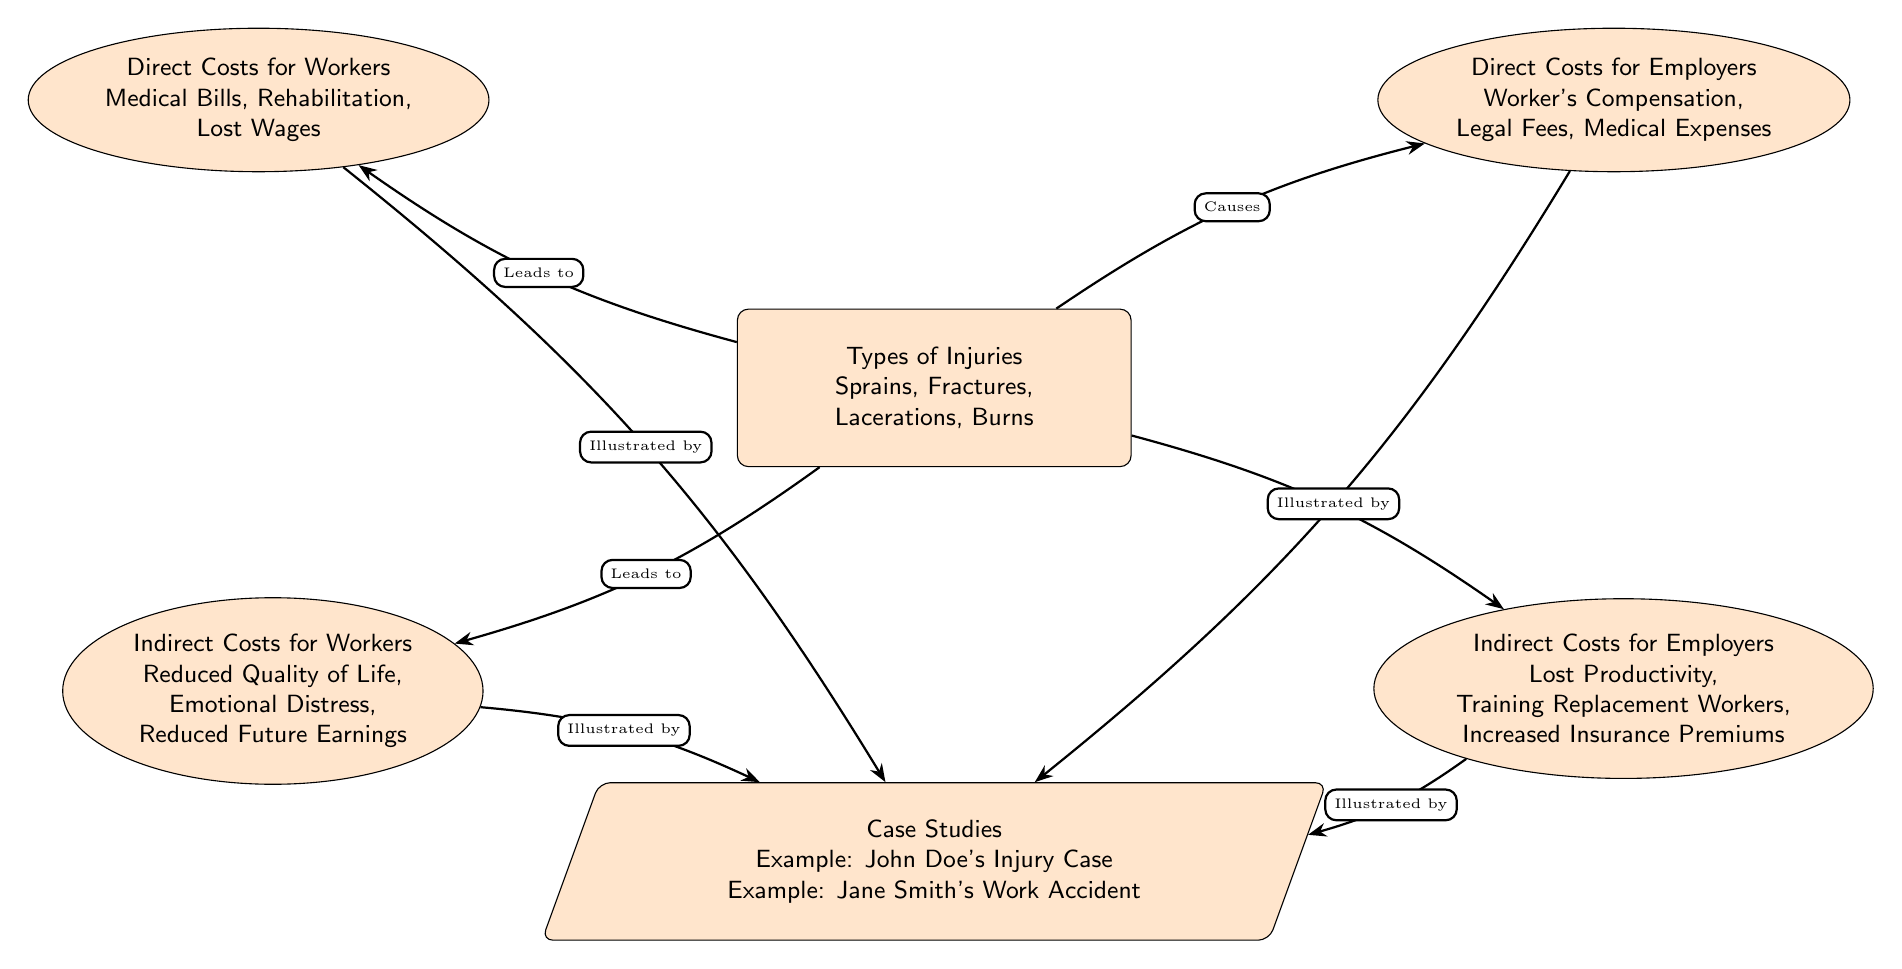What types of injuries are mentioned? The diagram lists the types of injuries directly from the main node titled "Types of Injuries." It includes "Sprains," "Fractures," "Lacerations," and "Burns."
Answer: Sprains, Fractures, Lacerations, Burns What are the direct costs for workers? The node designated as "Direct Costs for Workers" contains specific costs listed, which include "Medical Bills," "Rehabilitation," and "Lost Wages."
Answer: Medical Bills, Rehabilitation, Lost Wages What causes indirect costs for employers? The diagram shows that indirect costs for employers are specifically caused by injuries, as indicated by the arrow labeled "Causes" pointing from "Types of Injuries" to "Indirect Costs for Employers."
Answer: Injuries How many case studies are included in the diagram? The "Case Studies" node notes specific examples, indicating that there are at least two case studies listed: "John Doe's Injury Case" and "Jane Smith's Work Accident."
Answer: Two What leads to reduced quality of life for workers? The "Reduced Quality of Life" is mentioned under the node "Indirect Costs for Workers," which is directly connected to the main node "Types of Injuries" thus implying that injuries lead to this indirect cost.
Answer: Injuries Which costs are illustrated by case studies? Looking at the arrows in the diagram, it is noted that both direct and indirect costs for workers and employers are illustrated by the case studies. Thus, the costs mentioned are "Direct Costs for Workers," "Indirect Costs for Workers," "Direct Costs for Employers," and "Indirect Costs for Employers."
Answer: All costs Which node is positioned lower in the diagram, "Direct Costs for Workers" or "Indirect Costs for Employers"? By examining the vertical position of the nodes in the diagram, "Indirect Costs for Employers" is positioned lower than "Direct Costs for Workers," indicating its placement in the structural layout of the diagram.
Answer: Indirect Costs for Employers What is the relationship between "Types of Injuries" and "Direct Costs for Employers"? The diagram specifies a causal relationship indicated by an arrow from "Types of Injuries" to "Direct Costs for Employers," labeled "Causes," which shows that the former leads to the latter.
Answer: Causes What does the trapezium shape represent in the diagram? The trapezium shape in the diagram represents a case node, specifically indicating that it contains examples or case studies related to the economic impact of construction injuries.
Answer: Case Studies 